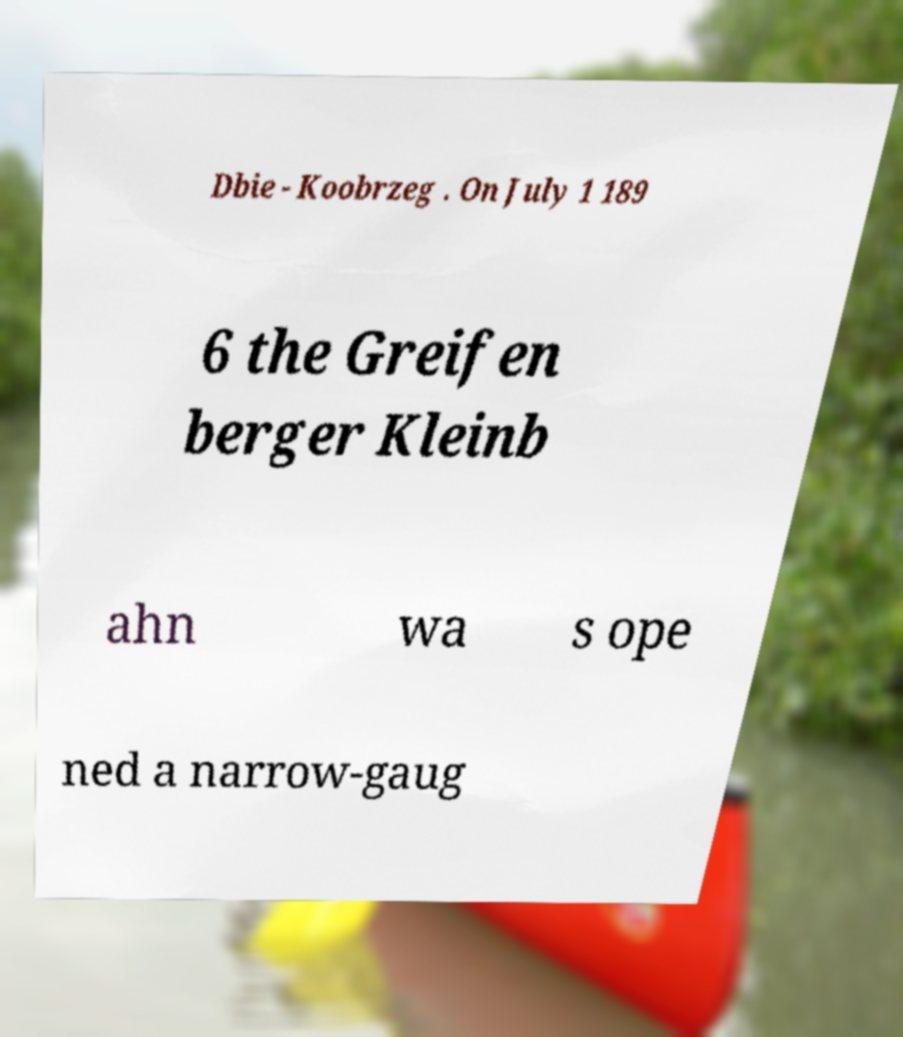Can you accurately transcribe the text from the provided image for me? Dbie - Koobrzeg . On July 1 189 6 the Greifen berger Kleinb ahn wa s ope ned a narrow-gaug 